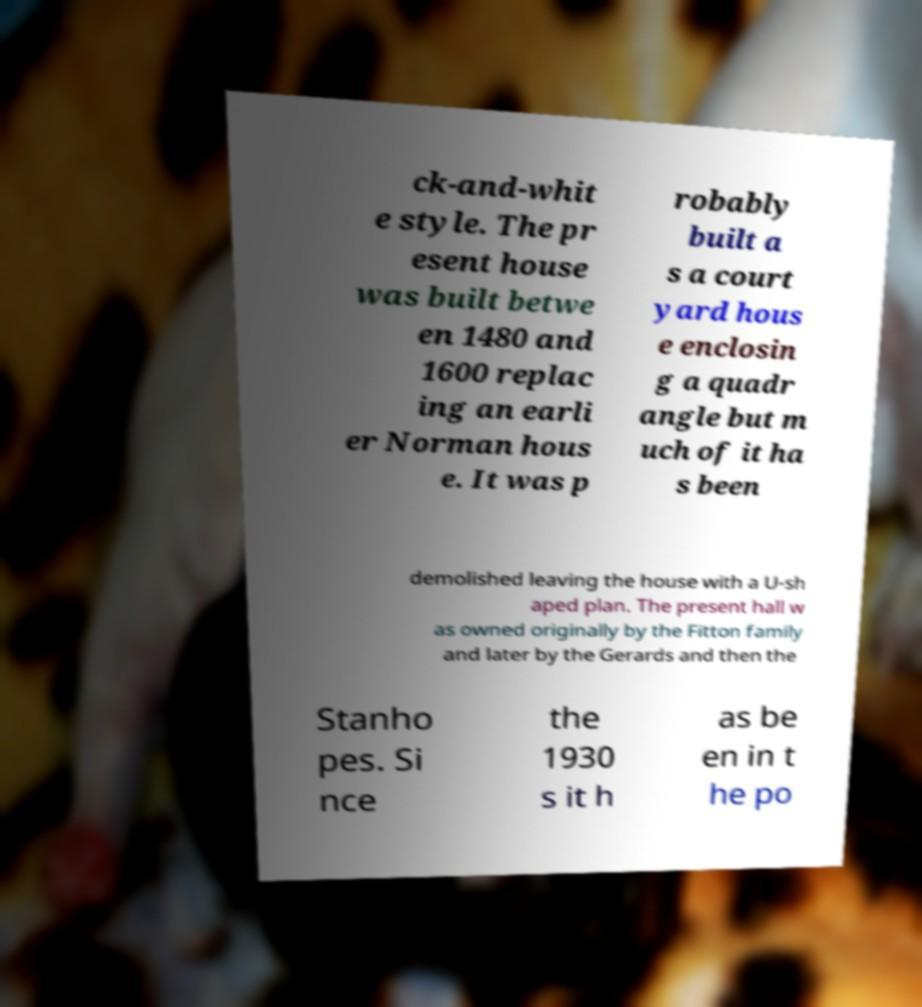There's text embedded in this image that I need extracted. Can you transcribe it verbatim? ck-and-whit e style. The pr esent house was built betwe en 1480 and 1600 replac ing an earli er Norman hous e. It was p robably built a s a court yard hous e enclosin g a quadr angle but m uch of it ha s been demolished leaving the house with a U-sh aped plan. The present hall w as owned originally by the Fitton family and later by the Gerards and then the Stanho pes. Si nce the 1930 s it h as be en in t he po 